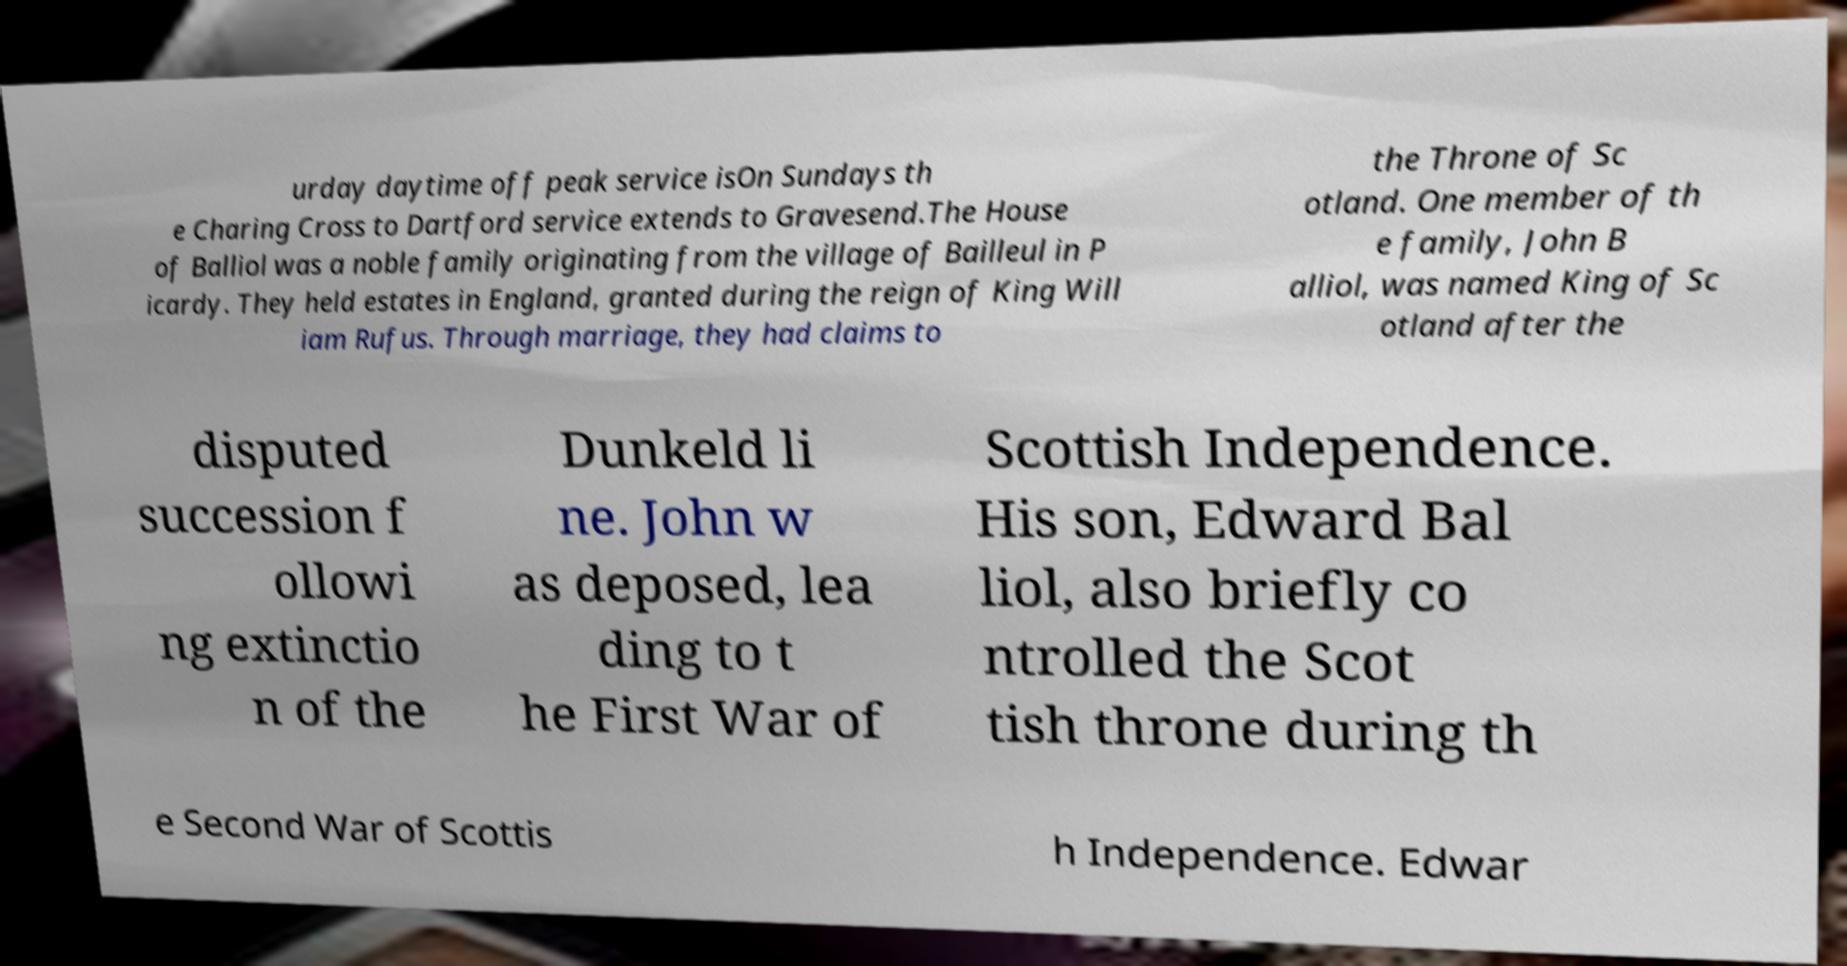Can you read and provide the text displayed in the image?This photo seems to have some interesting text. Can you extract and type it out for me? urday daytime off peak service isOn Sundays th e Charing Cross to Dartford service extends to Gravesend.The House of Balliol was a noble family originating from the village of Bailleul in P icardy. They held estates in England, granted during the reign of King Will iam Rufus. Through marriage, they had claims to the Throne of Sc otland. One member of th e family, John B alliol, was named King of Sc otland after the disputed succession f ollowi ng extinctio n of the Dunkeld li ne. John w as deposed, lea ding to t he First War of Scottish Independence. His son, Edward Bal liol, also briefly co ntrolled the Scot tish throne during th e Second War of Scottis h Independence. Edwar 